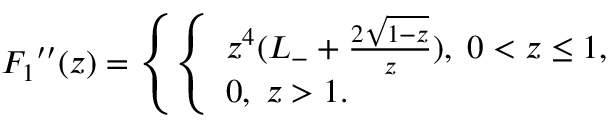<formula> <loc_0><loc_0><loc_500><loc_500>{ F _ { 1 } } ^ { \prime \prime } ( z ) = \left \{ \left \{ \begin{array} { l l } { { z ^ { 4 } ( L _ { - } + { \frac { 2 \sqrt { 1 - z } } { z } } ) , \, 0 < z \leq 1 , } } \\ { 0 , \, z > 1 . } \end{array}</formula> 